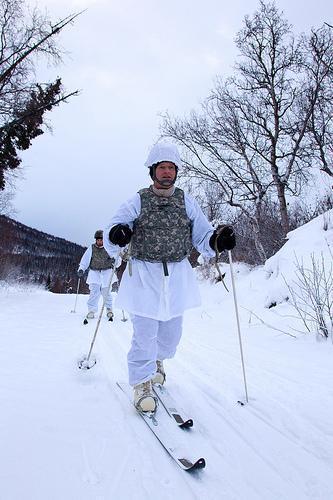How many people are in the picture?
Give a very brief answer. 2. 